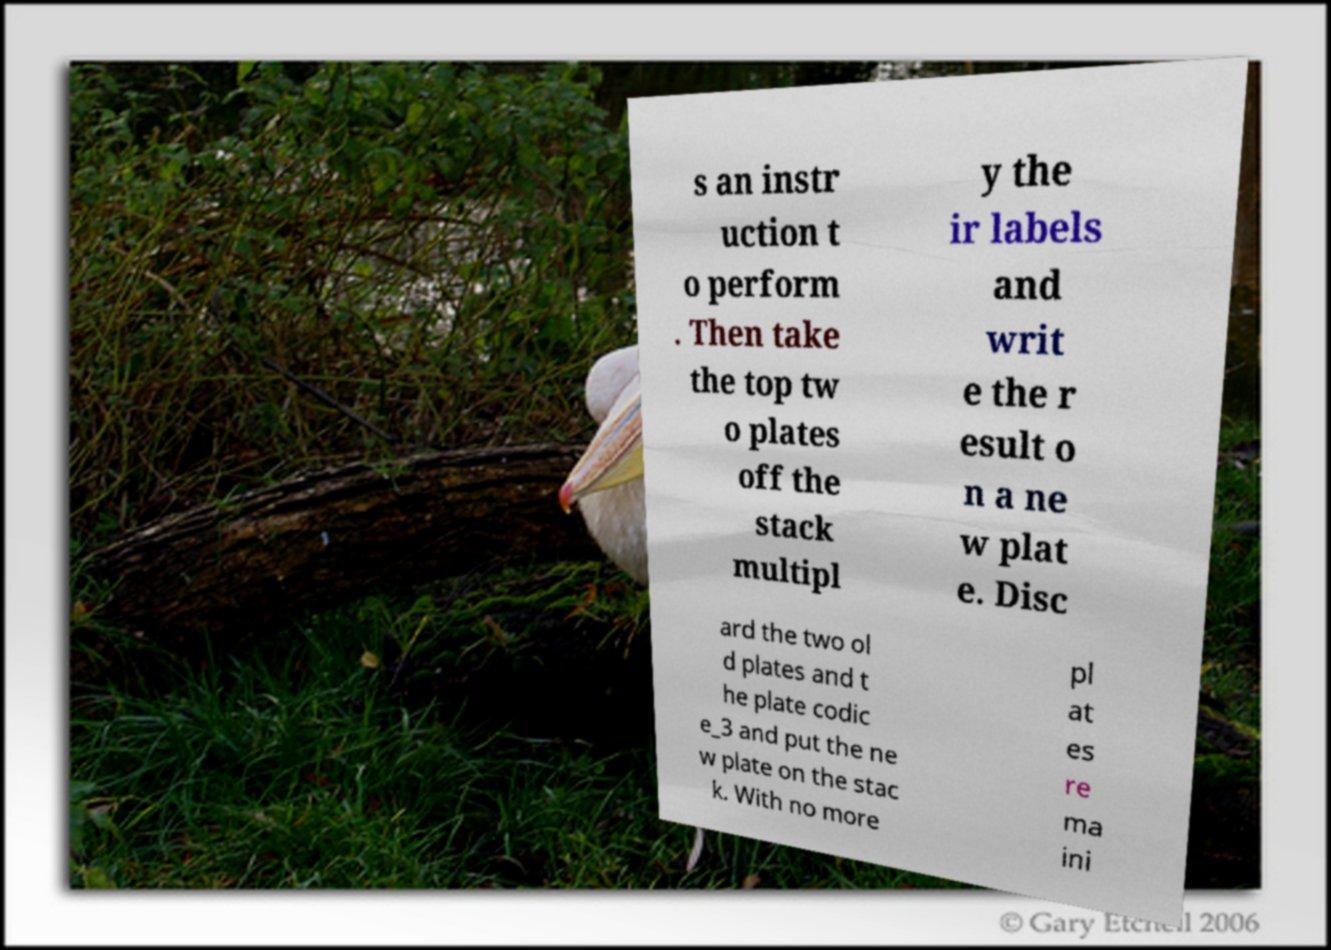Can you read and provide the text displayed in the image?This photo seems to have some interesting text. Can you extract and type it out for me? s an instr uction t o perform . Then take the top tw o plates off the stack multipl y the ir labels and writ e the r esult o n a ne w plat e. Disc ard the two ol d plates and t he plate codic e_3 and put the ne w plate on the stac k. With no more pl at es re ma ini 